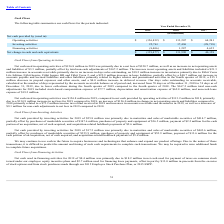According to Fitbit's financial document, Why did the days sales outstanding in accounts receivable increased from 70 days to 74 days between 2018 and 2019? Due to lower collections during the fourth quarter of 2019 compared to the fourth quarter of 2018.. The document states: "ember 31, 2018 to 74 days as of December 31, 2019, due to lower collections during the fourth quarter of 2019 compared to the fourth quarter of 2018. ..." Also, What factors led to net cash used in operating activities of $156.8 million in 2019? Due to a net loss of $320.7 million, as well as an increase in net operating assets and liabilities of $3.3 million, partially offset by total non-cash adjustments of $167.2 million.. The document states: "activities of $156.8 million in 2019 was primarily due to a net loss of $320.7 million, as well as an increase in net operating assets and liabilities..." Also, What was the net cash used in financing activities for 2019? According to the financial document, $8.4 million. The relevant text states: "Net cash used in financing activities for 2019 of $8.4 million was primarily due to $18.2 million in net cash used for payment of taxes on common stock..." Also, can you calculate: What was the difference in net cash provided by operating activities between 2017 and 2018? Based on the calculation: 113,207-64,241, the result is 48966 (in thousands). This is based on the information: "Operating activities $ (156,832) $ 113,207 $ 64,241 Operating activities $ (156,832) $ 113,207 $ 64,241..." The key data points involved are: 113,207, 64,241. Also, can you calculate: What was the percentage change for the total net change in cash and cash equivalents from 2017 to 2018? To answer this question, I need to perform calculations using the financial data. The calculation is: (131,990-40,158)/40,158, which equals 228.68 (percentage). This is based on the information: "cash and cash equivalents $ (139,477) $ 131,990 $ 40,158 change in cash and cash equivalents $ (139,477) $ 131,990 $ 40,158..." The key data points involved are: 131,990, 40,158. Also, can you calculate: What is the average net cash provided by investing activities for 2018 and 2019? To answer this question, I need to perform calculations using the financial data. The calculation is: (25,761+17,496)/2, which equals 21628.5 (in thousands). This is based on the information: "Investing activities 25,761 17,496 (28,718) Investing activities 25,761 17,496 (28,718)..." The key data points involved are: 17,496, 25,761. 